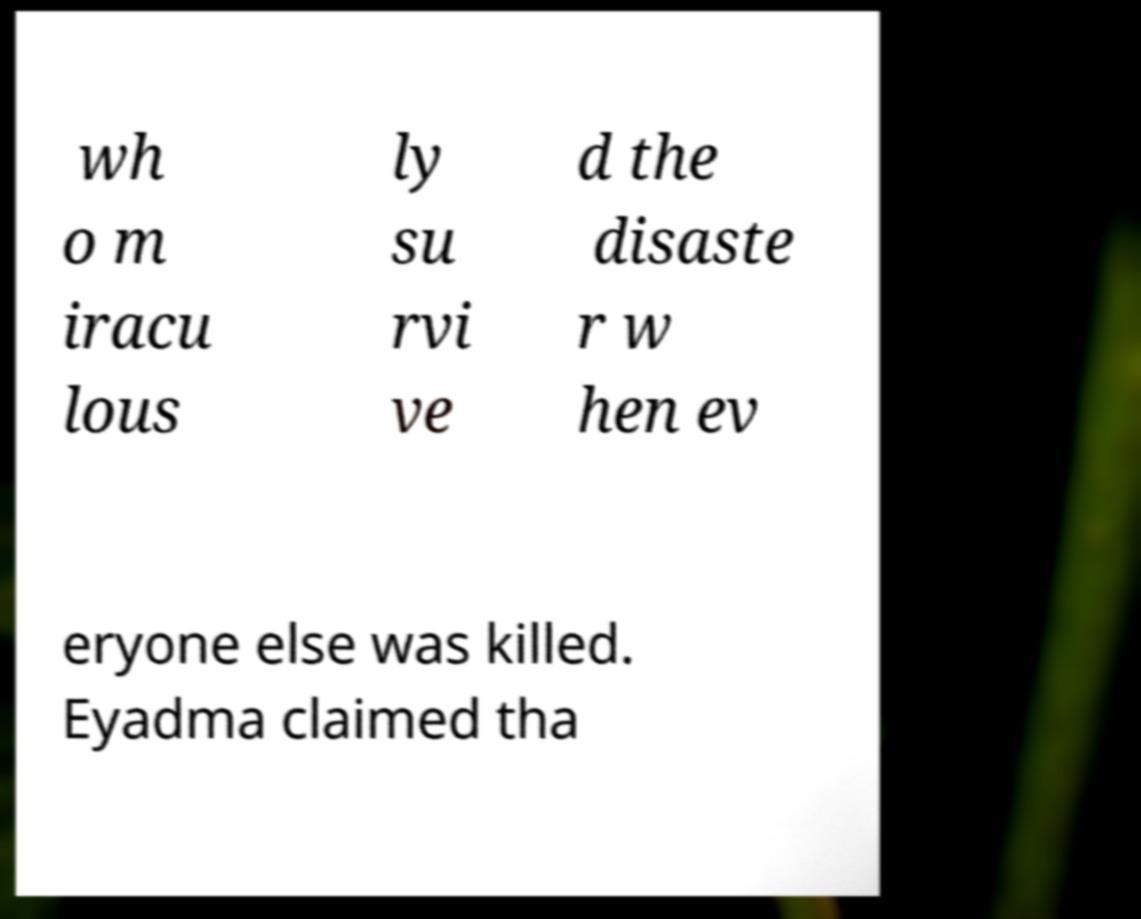Can you accurately transcribe the text from the provided image for me? wh o m iracu lous ly su rvi ve d the disaste r w hen ev eryone else was killed. Eyadma claimed tha 